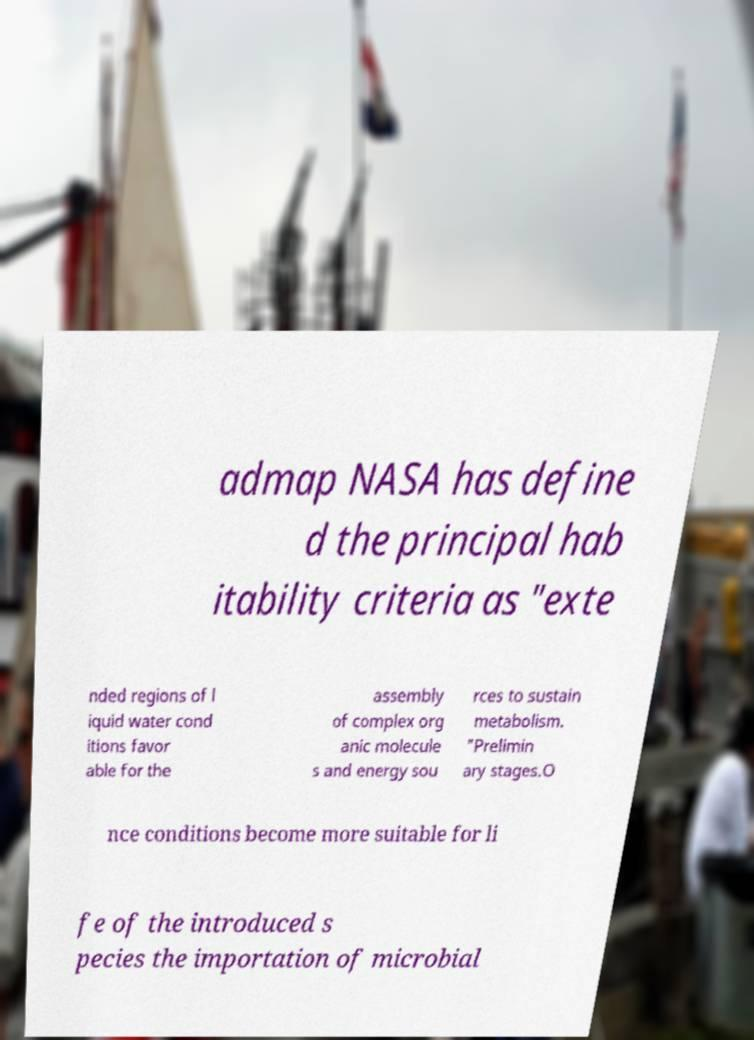What messages or text are displayed in this image? I need them in a readable, typed format. admap NASA has define d the principal hab itability criteria as "exte nded regions of l iquid water cond itions favor able for the assembly of complex org anic molecule s and energy sou rces to sustain metabolism. "Prelimin ary stages.O nce conditions become more suitable for li fe of the introduced s pecies the importation of microbial 